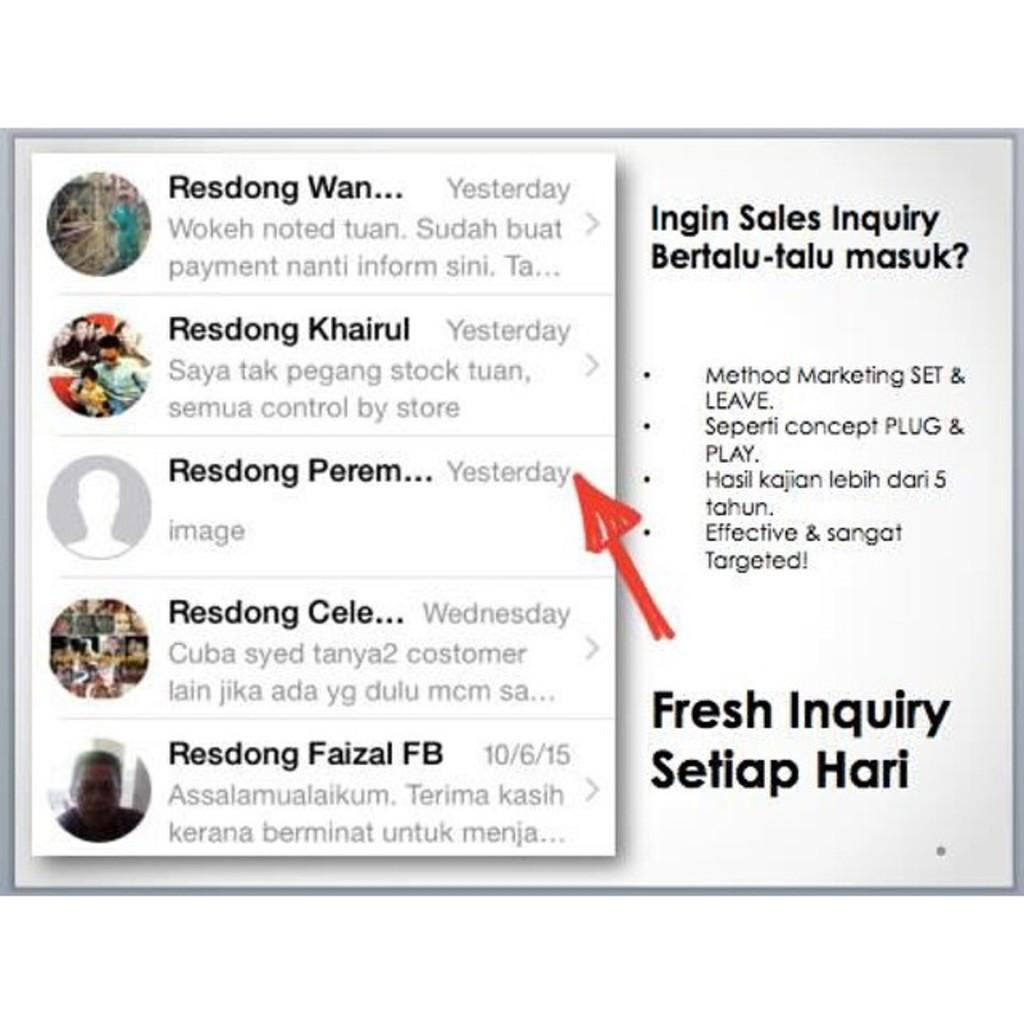What is the main feature of the image? There is a red color arrow in the image. What else can be seen in the image besides the arrow? There is text on the image and profile pictures of people are visible. What type of pickle is being offered in the image? There is no pickle present in the image. What question is being asked in the image? There is no question present in the image; only text, a red arrow, and profile pictures of people are visible. 